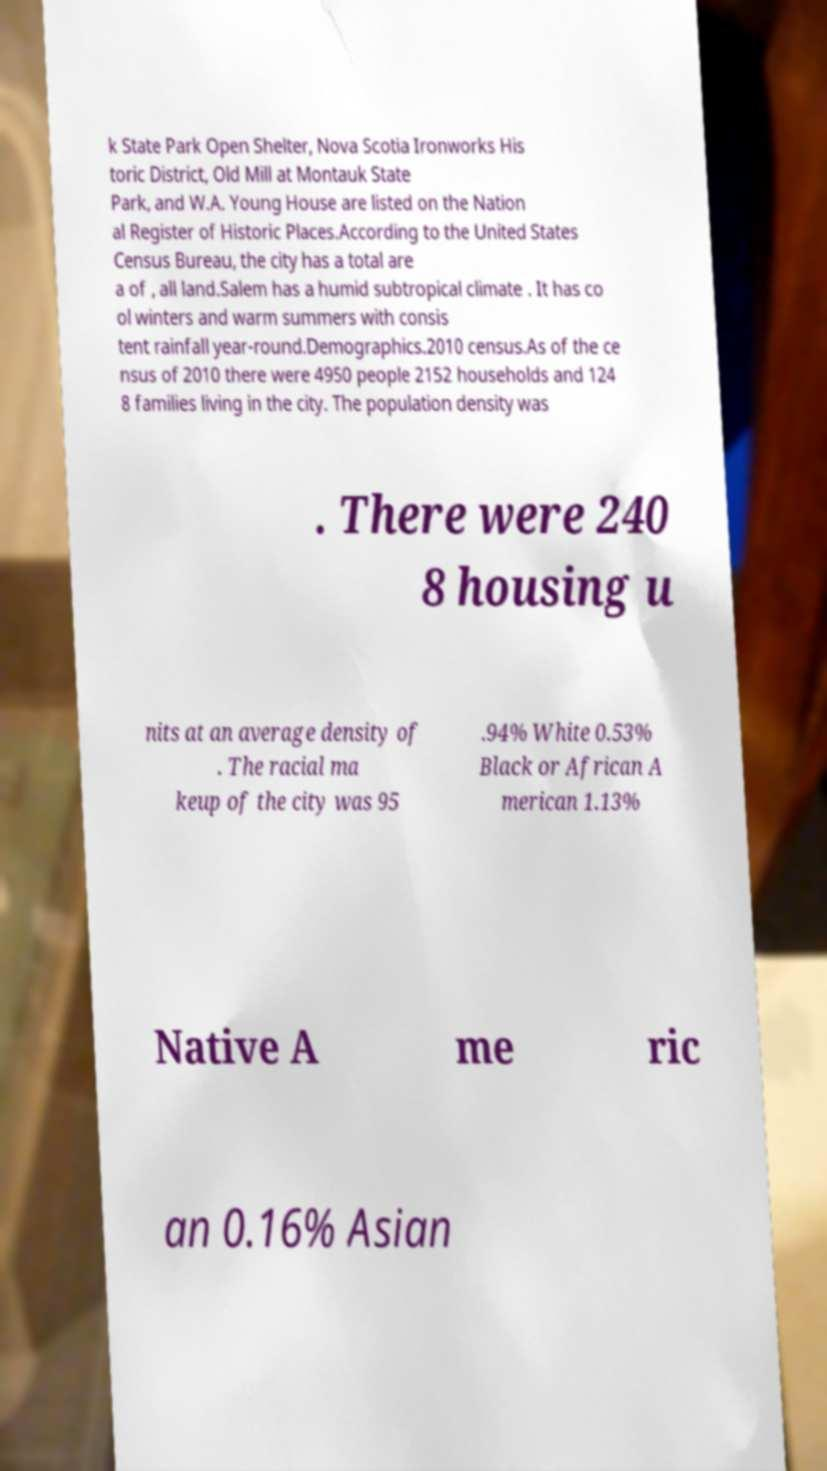Could you extract and type out the text from this image? k State Park Open Shelter, Nova Scotia Ironworks His toric District, Old Mill at Montauk State Park, and W.A. Young House are listed on the Nation al Register of Historic Places.According to the United States Census Bureau, the city has a total are a of , all land.Salem has a humid subtropical climate . It has co ol winters and warm summers with consis tent rainfall year-round.Demographics.2010 census.As of the ce nsus of 2010 there were 4950 people 2152 households and 124 8 families living in the city. The population density was . There were 240 8 housing u nits at an average density of . The racial ma keup of the city was 95 .94% White 0.53% Black or African A merican 1.13% Native A me ric an 0.16% Asian 